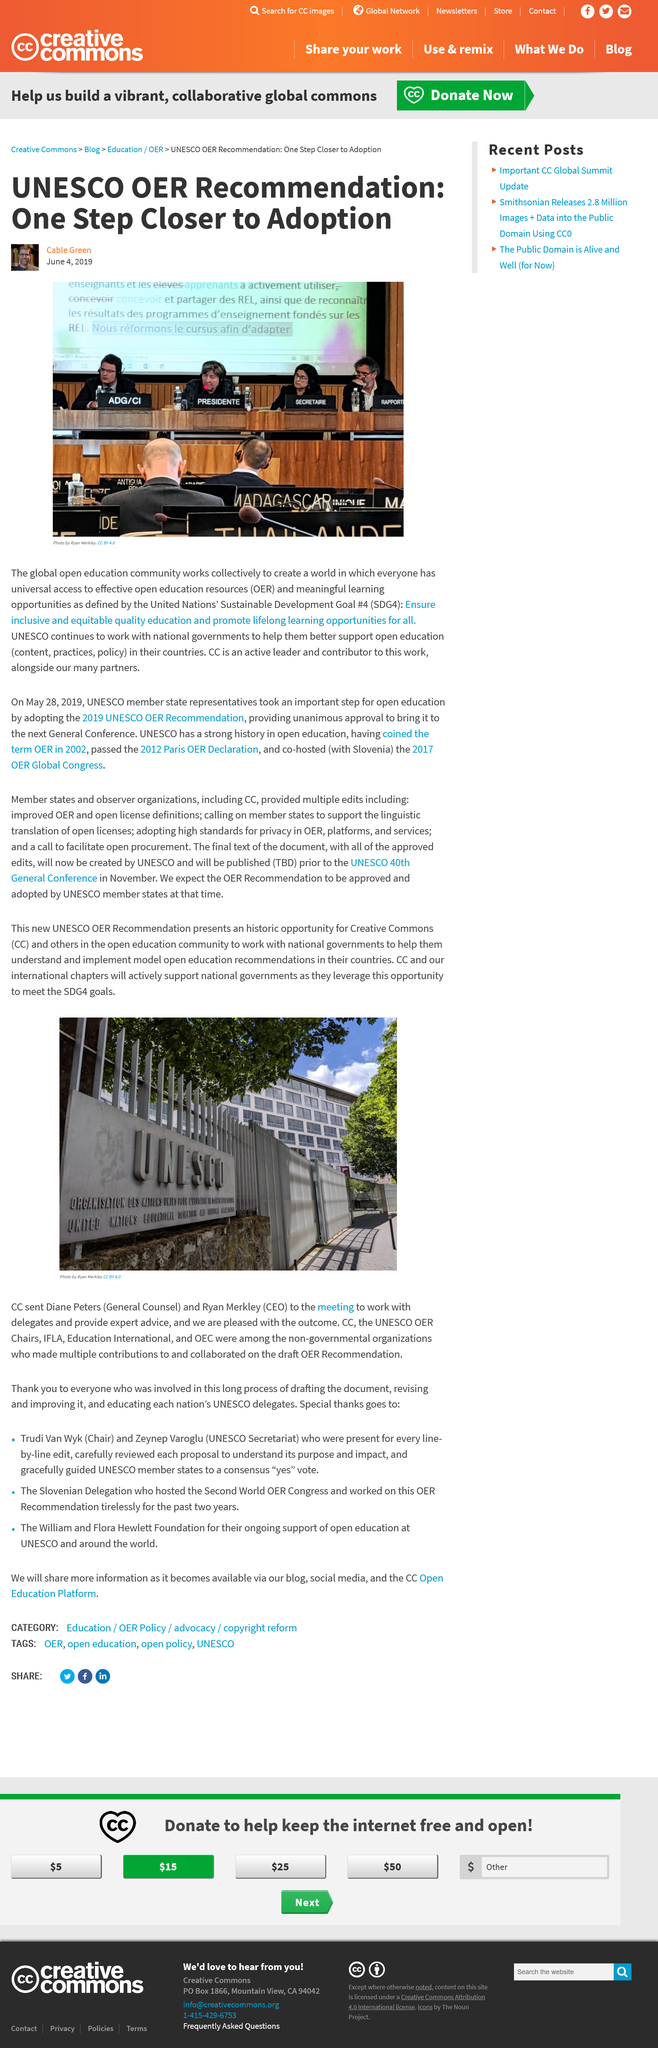List a handful of essential elements in this visual. UNESCO stands for the United Nations' Sustainable Development Goals, working towards a more sustainable and equitable future for all. The author of this article is Cable Green. 